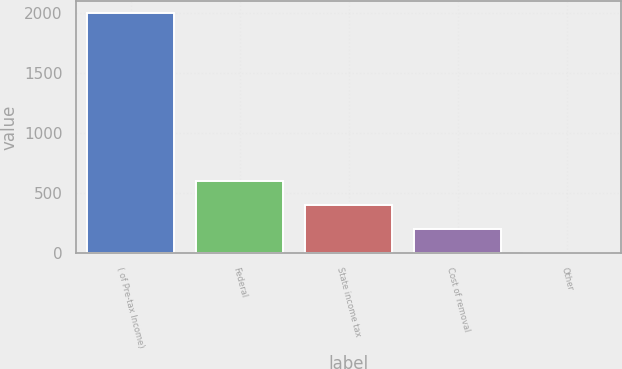<chart> <loc_0><loc_0><loc_500><loc_500><bar_chart><fcel>( of Pre-tax Income)<fcel>Federal<fcel>State income tax<fcel>Cost of removal<fcel>Other<nl><fcel>2002<fcel>602.7<fcel>402.8<fcel>202.9<fcel>3<nl></chart> 